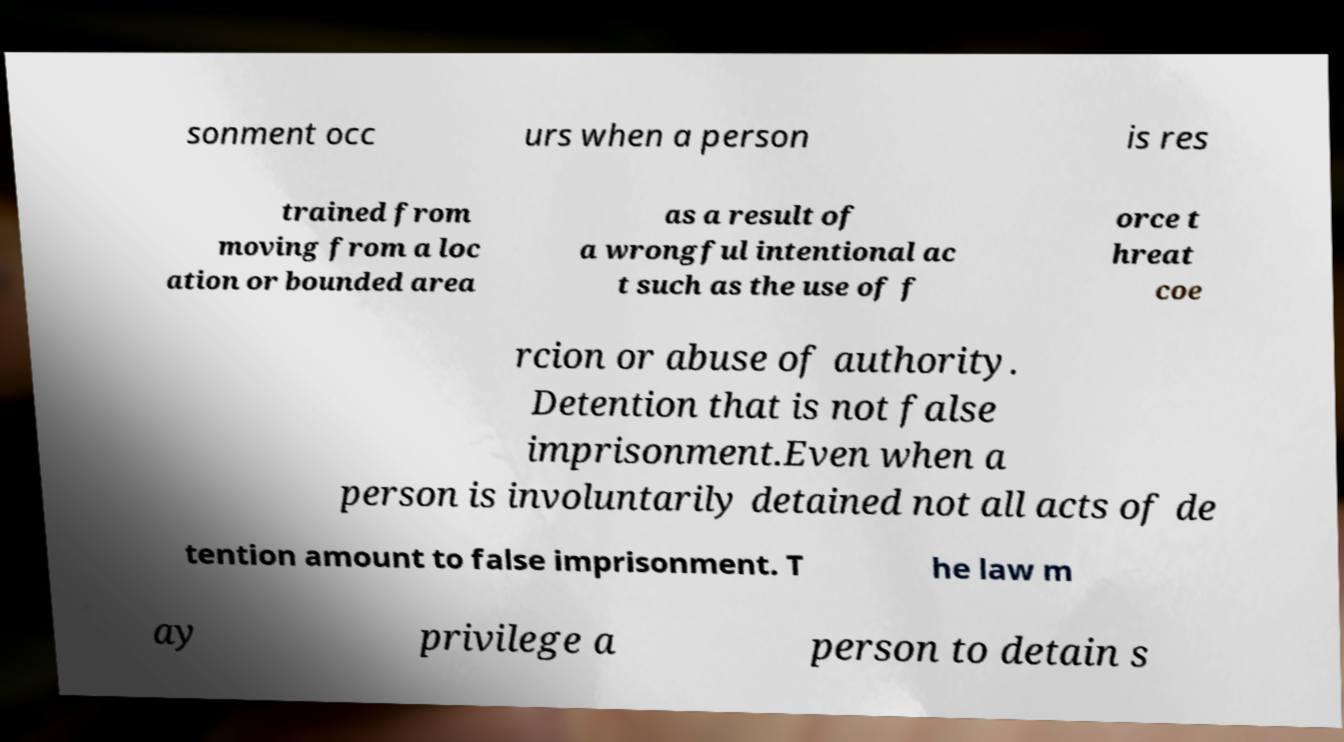What messages or text are displayed in this image? I need them in a readable, typed format. sonment occ urs when a person is res trained from moving from a loc ation or bounded area as a result of a wrongful intentional ac t such as the use of f orce t hreat coe rcion or abuse of authority. Detention that is not false imprisonment.Even when a person is involuntarily detained not all acts of de tention amount to false imprisonment. T he law m ay privilege a person to detain s 